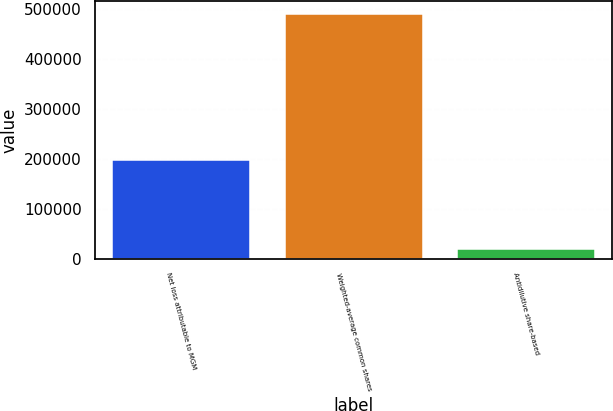Convert chart to OTSL. <chart><loc_0><loc_0><loc_500><loc_500><bar_chart><fcel>Net loss attributable to MGM<fcel>Weighted-average common shares<fcel>Antidilutive share-based<nl><fcel>197035<fcel>490875<fcel>19254<nl></chart> 